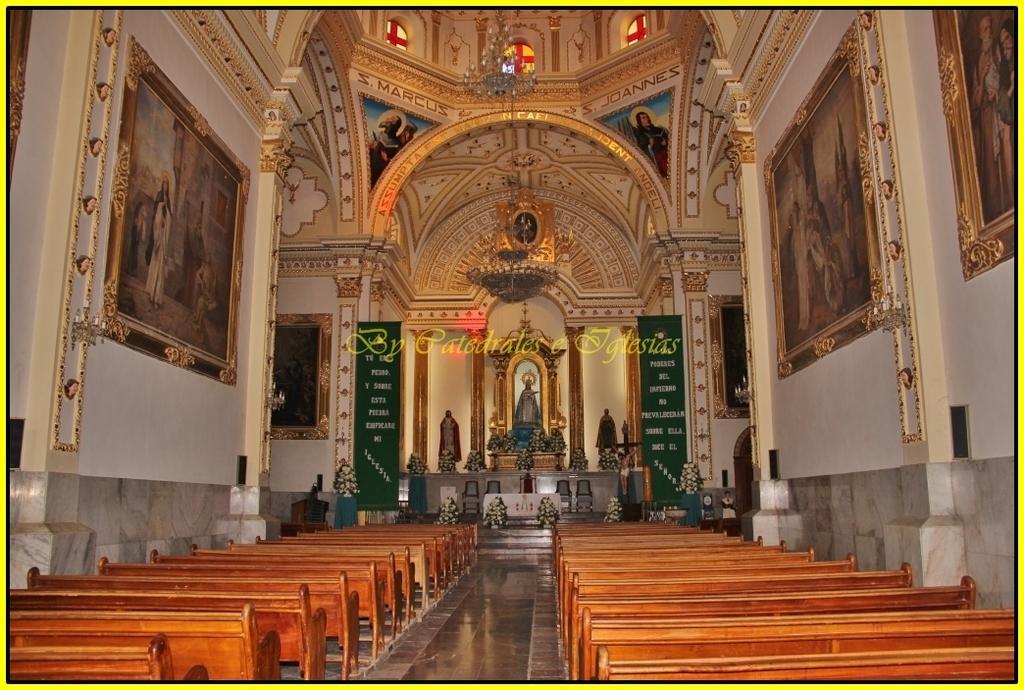Could you give a brief overview of what you see in this image? In this image I can see benches, wall paintings on a wall, boards, houseplants, statues, idols and a chandelier is hanged on a rooftop. This image is taken may be in a church. 